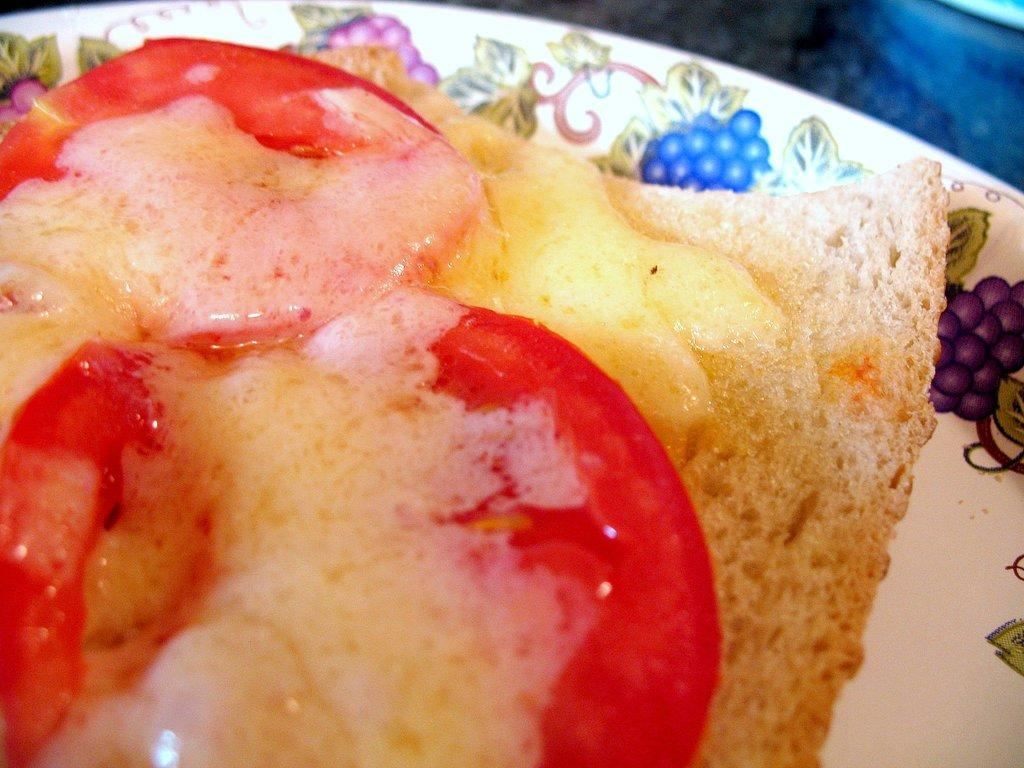What type of food is in the image? There is a sandwich in the image. How is the sandwich presented? The sandwich is on a plate. What ingredients are included in the sandwich? The sandwich contains tomatoes and bread. What color is the plate? The plate is white. How many cherries are on the plate in the image? There are no cherries present in the image; it features a sandwich on a white plate. What type of division is taking place in the image? There is no division taking place in the image; it shows a sandwich with tomatoes and bread on a white plate. 